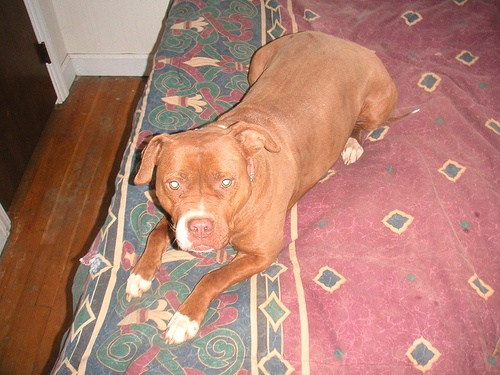Describe the objects in this image and their specific colors. I can see bed in black, salmon, brown, darkgray, and gray tones and dog in black, salmon, and tan tones in this image. 